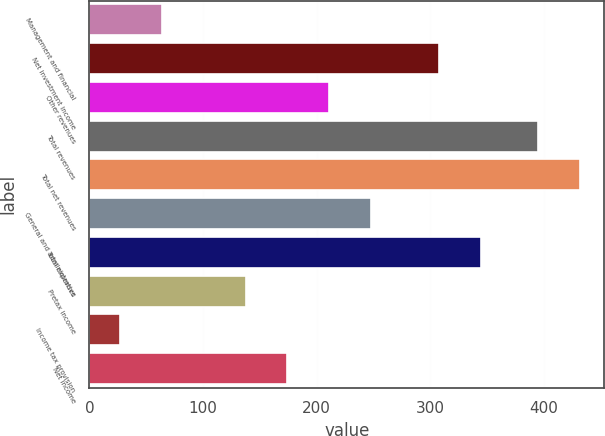Convert chart. <chart><loc_0><loc_0><loc_500><loc_500><bar_chart><fcel>Management and financial<fcel>Net investment income<fcel>Other revenues<fcel>Total revenues<fcel>Total net revenues<fcel>General and administrative<fcel>Total expenses<fcel>Pretax income<fcel>Income tax provision<fcel>Net income<nl><fcel>63.8<fcel>308<fcel>211<fcel>395<fcel>431.8<fcel>247.8<fcel>344.8<fcel>137.4<fcel>27<fcel>174.2<nl></chart> 